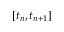<formula> <loc_0><loc_0><loc_500><loc_500>[ t _ { n } , t _ { n + 1 } ]</formula> 